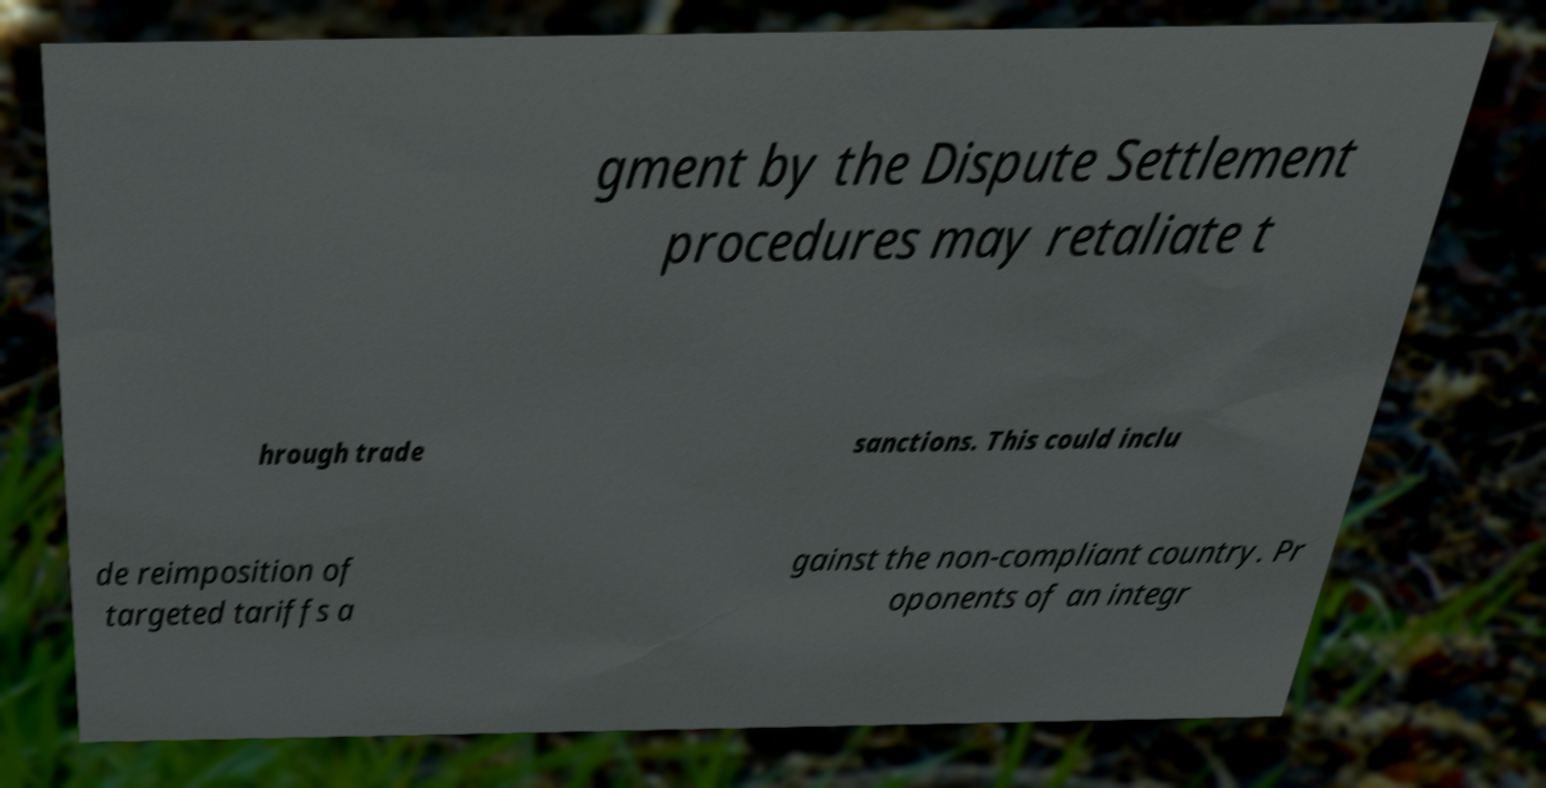For documentation purposes, I need the text within this image transcribed. Could you provide that? gment by the Dispute Settlement procedures may retaliate t hrough trade sanctions. This could inclu de reimposition of targeted tariffs a gainst the non-compliant country. Pr oponents of an integr 